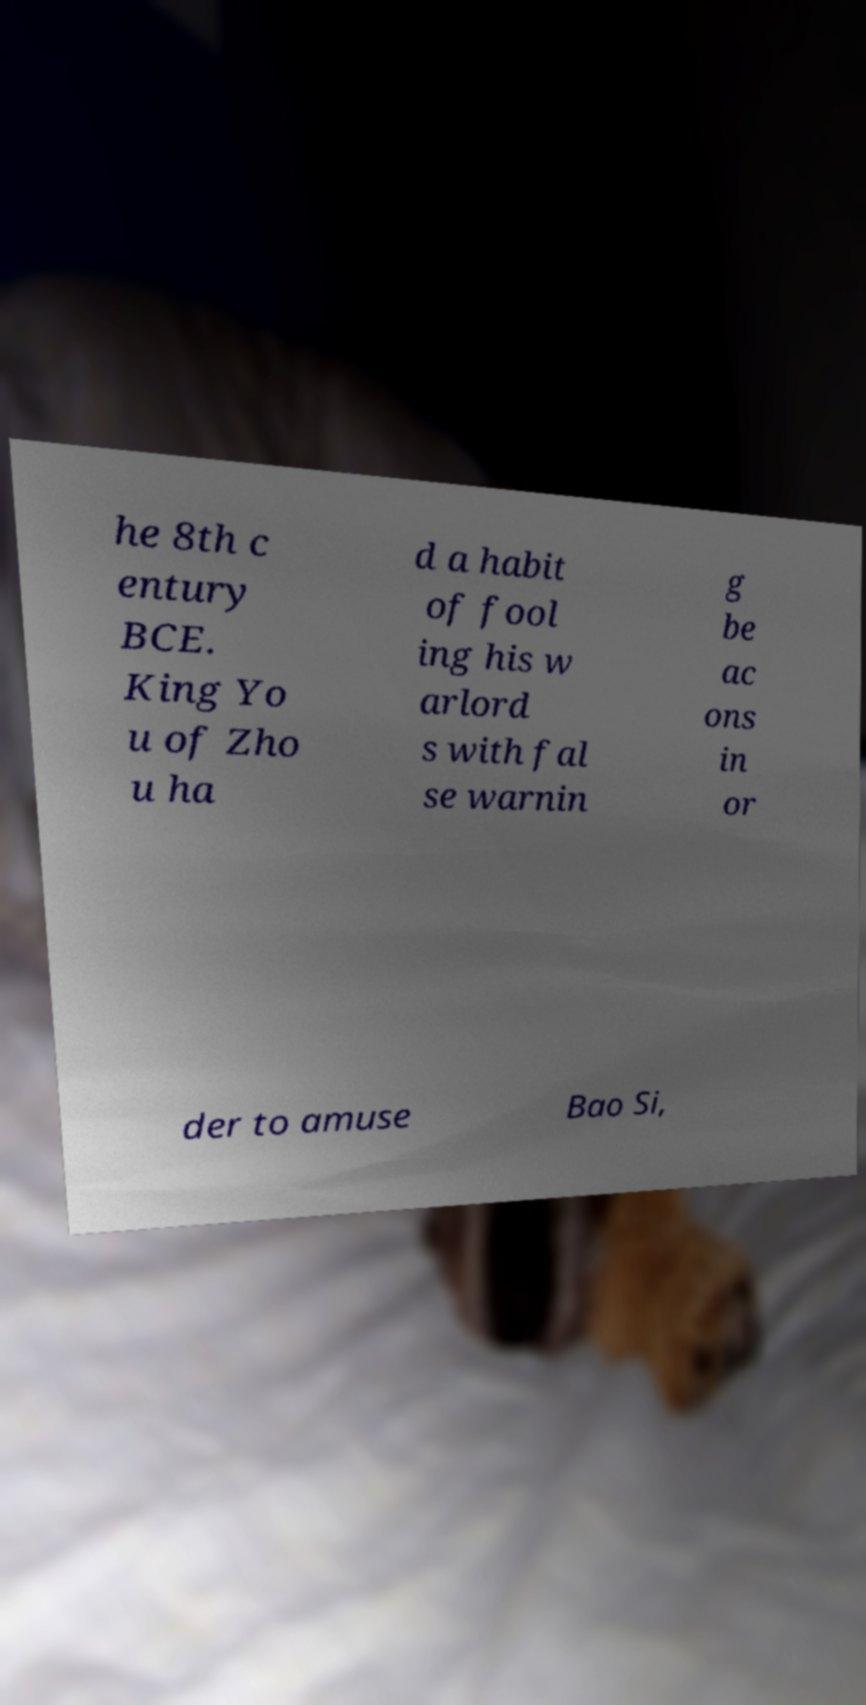Please identify and transcribe the text found in this image. he 8th c entury BCE. King Yo u of Zho u ha d a habit of fool ing his w arlord s with fal se warnin g be ac ons in or der to amuse Bao Si, 